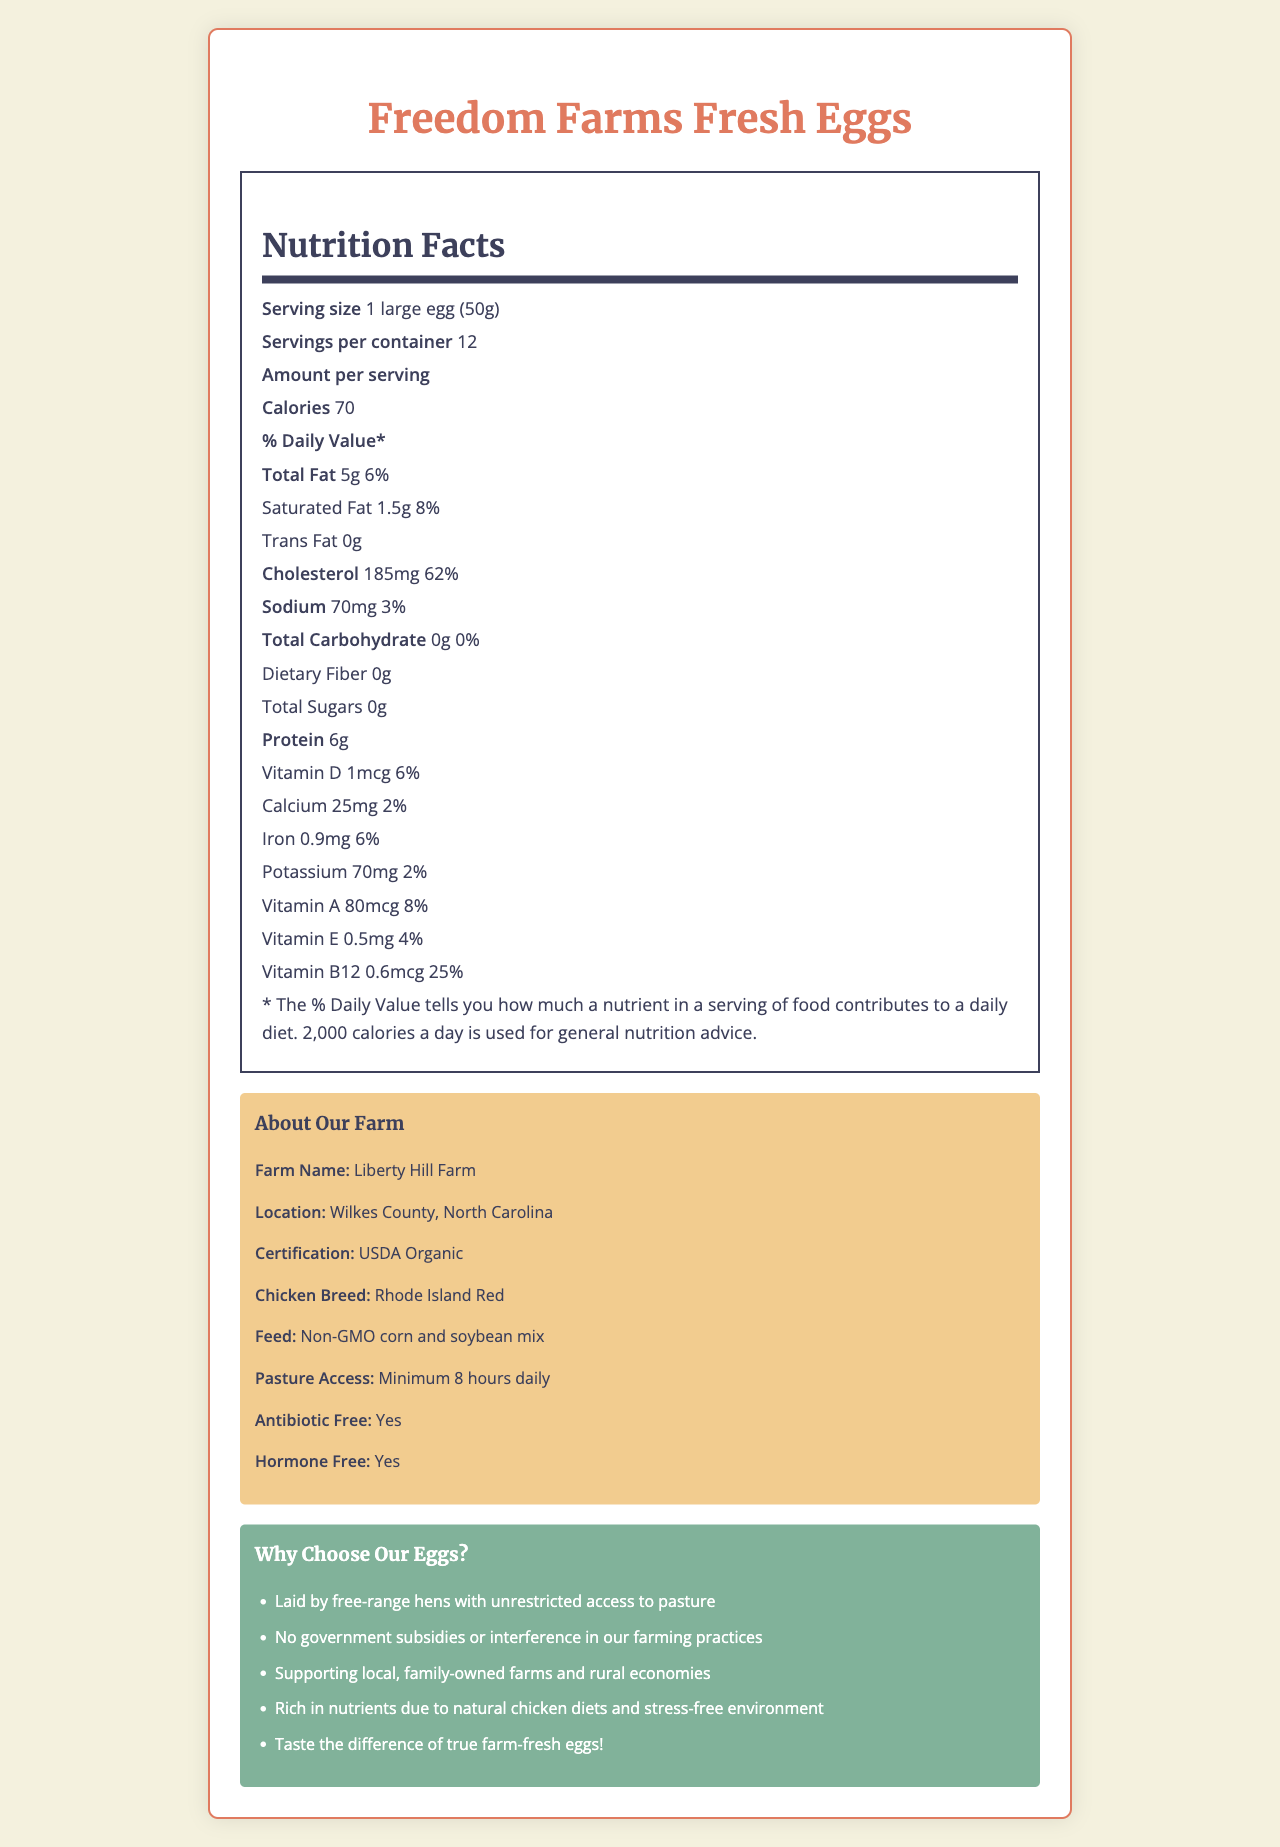what is the serving size? The document states that the serving size is 1 large egg, which weighs 50 grams.
Answer: 1 large egg (50g) how many calories are in one serving? The amount of calories per serving is listed as 70.
Answer: 70 what is the percentage of the daily value for cholesterol? The document lists the daily value percentage for cholesterol as 62%.
Answer: 62% how much protein does one egg contain? The document states that one egg contains 6 grams of protein.
Answer: 6g what is the farm's location? The document specifies that the farm's location is Wilkes County, North Carolina.
Answer: Wilkes County, North Carolina which vitamin has the highest daily value percentage? The daily value percentage for cholesterol is 62%, the highest among listed vitamins and minerals.
Answer: Cholesterol how much calcium is in one egg? A. 15mg B. 25mg C. 30mg D. 50mg The document lists the calcium content as 25mg.
Answer: B. 25mg which of the following is true about the farm? A. Uses GMO feed B. Chickens are confined throughout the day C. Certified USDA Organic D. Located in New York The document states the farm is USDA Organic certified.
Answer: C. Certified USDA Organic do the chickens have antibiotic-free feed? The document mentions that the chickens are antibiotic-free.
Answer: Yes summarize the main idea of the document. The main idea covers the nutritional content of the eggs and discusses the farm's practices, location, and marketing claims aimed at promoting the quality and natural farming methods of their product.
Answer: The document provides detailed nutrition facts and additional farm-related information about Freedom Farms Fresh Eggs, emphasizing their organic and free-range practices. are the marketing claims supported by government subsidies? The document explicitly states "No government subsidies or interference in our farming practices."
Answer: No how many grams of dietary fiber are in one egg? The document lists the dietary fiber content as 0 grams.
Answer: 0g what breed of chickens is used? The document states that the breed of chicken used is Rhode Island Red.
Answer: Rhode Island Red how much sodium is in one serving? The sodium content per serving is listed as 70mg.
Answer: 70mg what is the vitamin D content in one egg? The document specifies the vitamin D content as 1 microgram (mcg).
Answer: 1mcg cannot be determined from the visual information how the chickens are treated beyond being free-range The document does not provide detailed information on how the chickens are treated beyond the fact that they are free-range with unrestricted access to pasture.
Answer: Not enough information 